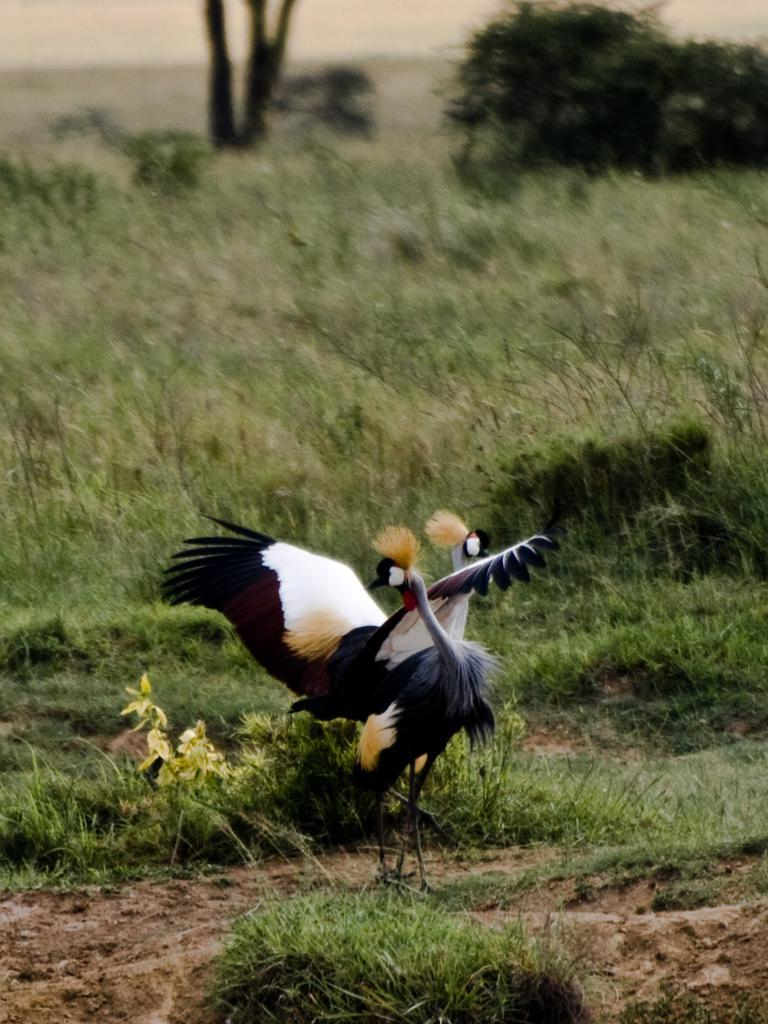What is located in the center of the image? There are birds in the center of the image. What can be seen in the background of the image? There are trees in the background of the image. What type of vegetation covers the ground in the image? The ground is covered with grass at the bottom of the image. What type of toy can be seen in the hands of the birds in the image? There are no toys present in the image, and the birds do not have any objects in their hands. 